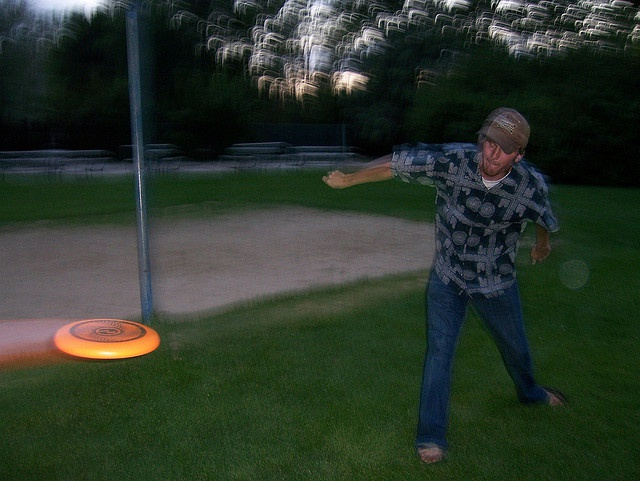Describe the objects in this image and their specific colors. I can see people in gray, black, navy, and darkblue tones, frisbee in gray, orange, brown, and salmon tones, bench in gray and black tones, bench in gray, black, and darkblue tones, and bench in gray, black, and darkblue tones in this image. 